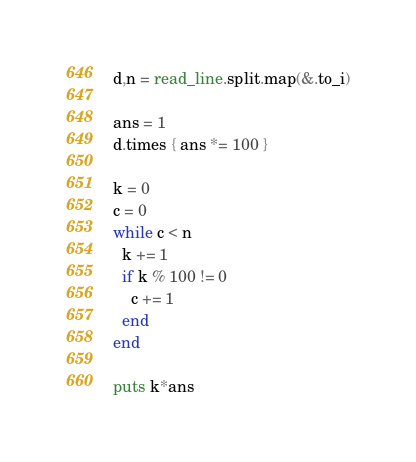<code> <loc_0><loc_0><loc_500><loc_500><_Crystal_>d,n = read_line.split.map(&.to_i)

ans = 1
d.times { ans *= 100 }

k = 0
c = 0
while c < n
  k += 1
  if k % 100 != 0
    c += 1
  end
end

puts k*ans
</code> 